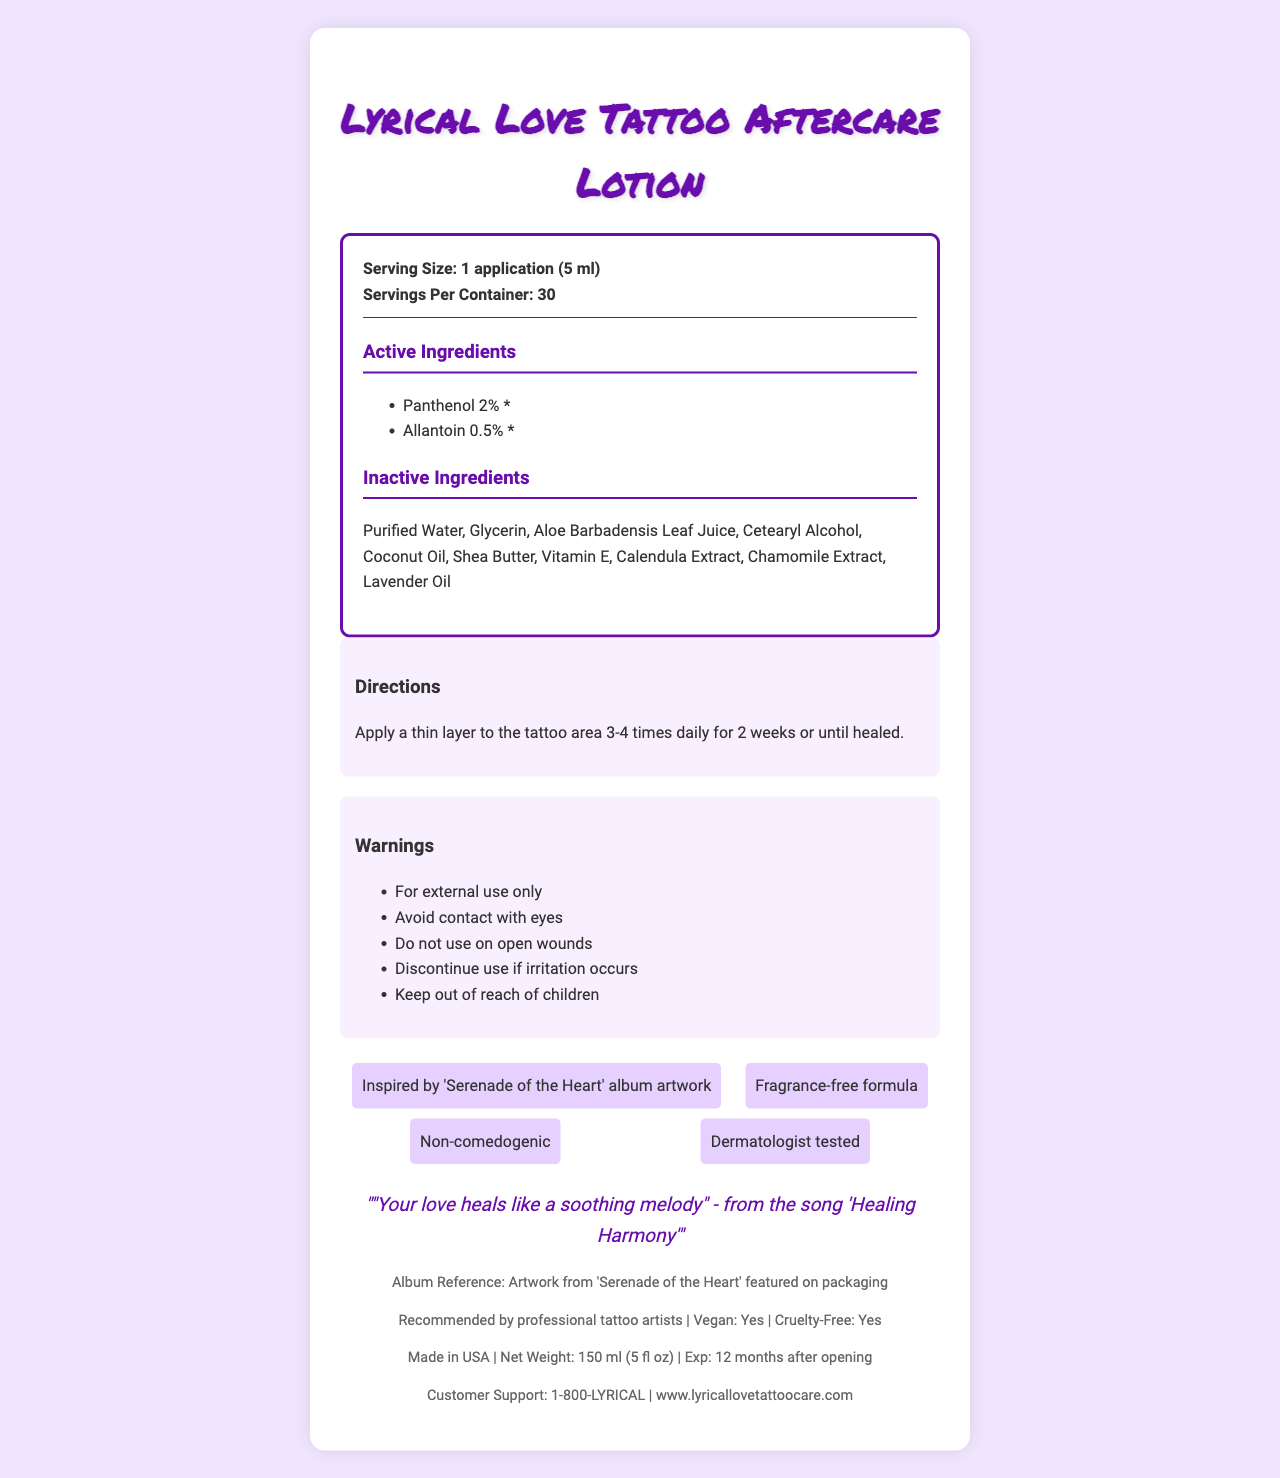what is the product name? The product name is "Lyrical Love Tattoo Aftercare Lotion" as mentioned at the top of the document.
Answer: Lyrical Love Tattoo Aftercare Lotion how many servings are there per container? The document specifies that there are 30 servings per container.
Answer: 30 what are the active ingredients? The active ingredients listed are Panthenol (2%) and Allantoin (0.5%).
Answer: Panthenol, Allantoin how often should the lotion be applied to the tattoo area? The directions state to apply a thin layer to the tattoo area 3-4 times daily.
Answer: 3-4 times daily what is the expiry period after opening the container? The document mentions that the expiration period is 12 months after opening.
Answer: 12 months who recommends this lotion? A. Dermatologists B. Professional Tattoo Artists C. Both D. Neither The document clearly states that the lotion is recommended by professional tattoo artists.
Answer: B. Professional Tattoo Artists where is the product made? A. Canada B. USA C. UK D. Australia The product is marked as made in the USA.
Answer: B. USA is the product fragrance-free? One of the features mentioned is that the product has a fragrance-free formula.
Answer: Yes does the document contain information about the carbon footprint of the product? There is no mention of the product's carbon footprint in the document.
Answer: No how much Panthenol is in one serving? The document lists Panthenol as an active ingredient with an amount of 2%.
Answer: 2% how is the "Lyrical Love Tattoo Aftercare Lotion" connected to music? The document mentions that the lotion is inspired by album artwork and includes lyrical inspiration from a song.
Answer: Its packaging features artwork from the 'Serenade of the Heart' album, and it includes a lyrical inspiration from the song 'Healing Harmony'. what is in the directions section? The directions section advises applying the lotion 3-4 times daily for 2 weeks or until healed.
Answer: Apply a thin layer to the tattoo area 3-4 times daily for 2 weeks or until healed. summarize the main idea of the document. The summary includes all the primary elements and characteristics of the product as detailed in the document.
Answer: The document provides details about "Lyrical Love Tattoo Aftercare Lotion," including its active and inactive ingredients, directions for use, warnings, and special features. The lotion is fragrance-free, vegan, cruelty-free, and recommended by professional tattoo artists. It is inspired by the 'Serenade of the Heart' album artwork and contains a lyrical quote from the song 'Healing Harmony'. what is the net weight of the lotion container? The net weight of the lotion container is specified as 150 ml (5 fl oz).
Answer: 150 ml (5 fl oz) which ingredient is not listed? A. Vitamin C B. Glycerin C. Shea Butter D. Lavender Oil The inactive ingredients include Glycerin, Shea Butter, and Lavender Oil, but not Vitamin C.
Answer: A. Vitamin C does the label mention whether the lotion can be used on open wounds? The document includes a warning that says, "Do not use on open wounds."
Answer: No 